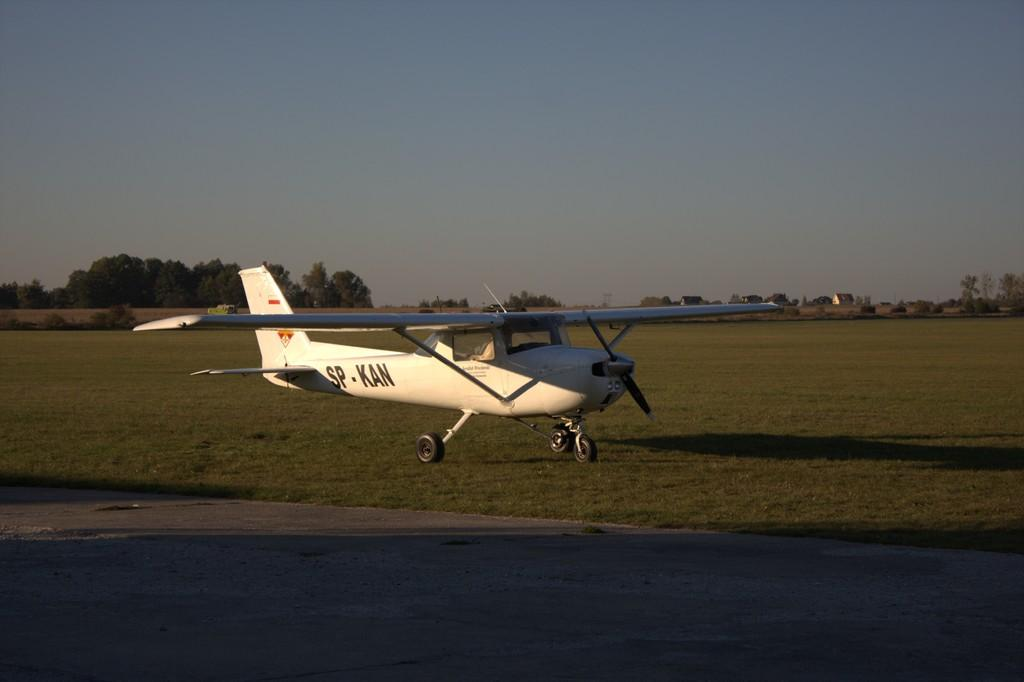<image>
Create a compact narrative representing the image presented. a plane on a run way with SP-KAN on the side 